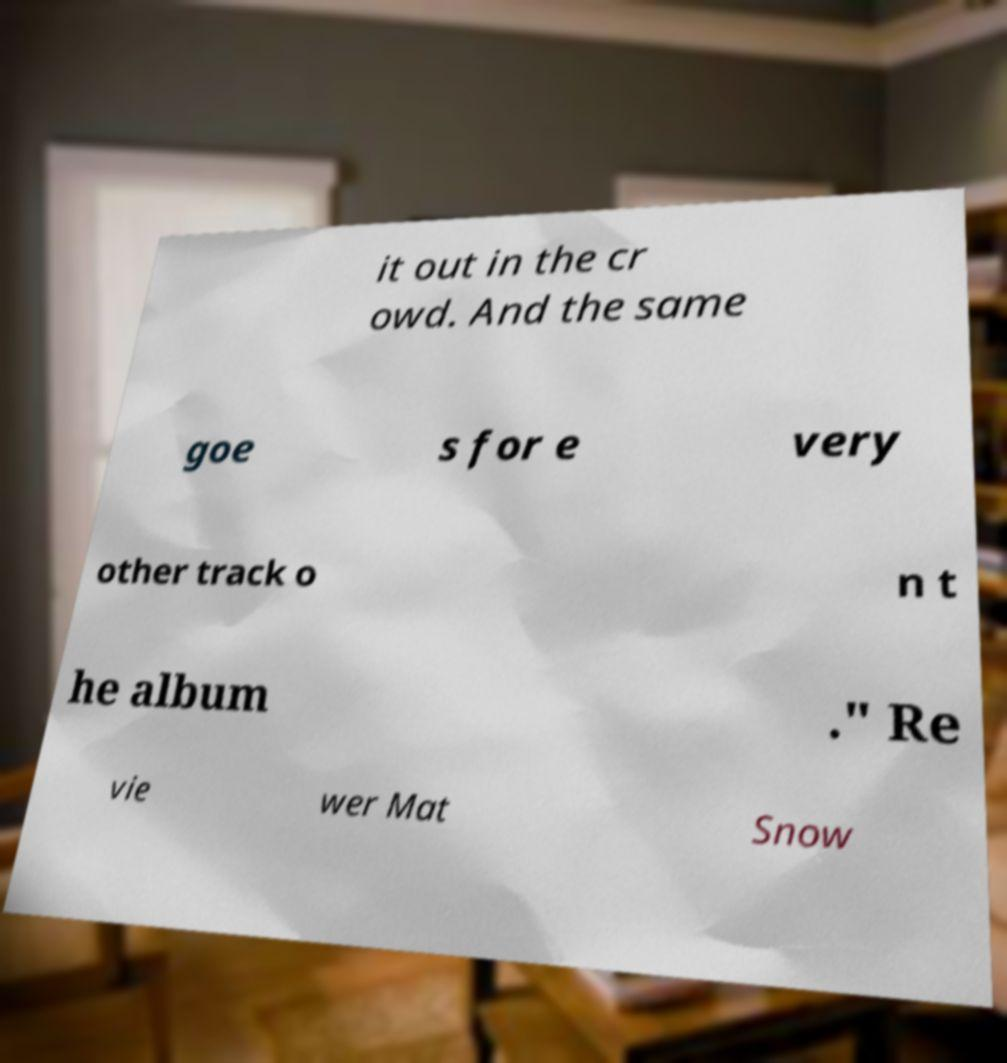Could you extract and type out the text from this image? it out in the cr owd. And the same goe s for e very other track o n t he album ." Re vie wer Mat Snow 